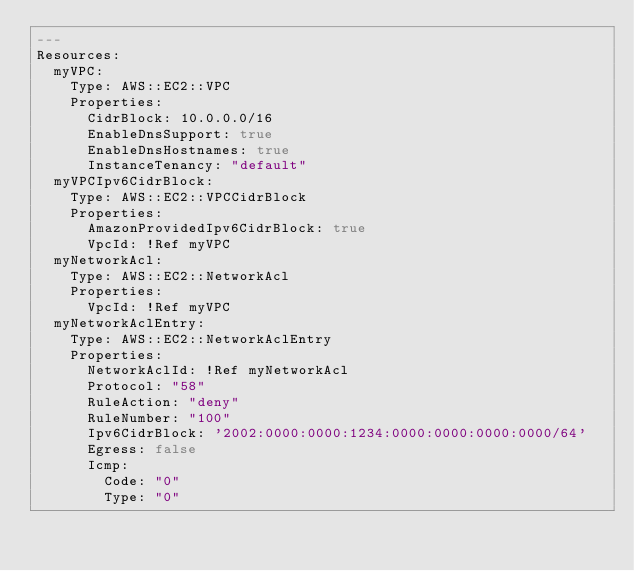<code> <loc_0><loc_0><loc_500><loc_500><_YAML_>---
Resources:
  myVPC:
    Type: AWS::EC2::VPC
    Properties:
      CidrBlock: 10.0.0.0/16
      EnableDnsSupport: true
      EnableDnsHostnames: true
      InstanceTenancy: "default"
  myVPCIpv6CidrBlock:
    Type: AWS::EC2::VPCCidrBlock
    Properties: 
      AmazonProvidedIpv6CidrBlock: true
      VpcId: !Ref myVPC
  myNetworkAcl:
    Type: AWS::EC2::NetworkAcl
    Properties:
      VpcId: !Ref myVPC
  myNetworkAclEntry:
    Type: AWS::EC2::NetworkAclEntry
    Properties:
      NetworkAclId: !Ref myNetworkAcl
      Protocol: "58"
      RuleAction: "deny"
      RuleNumber: "100"
      Ipv6CidrBlock: '2002:0000:0000:1234:0000:0000:0000:0000/64'
      Egress: false
      Icmp:
        Code: "0"
        Type: "0"
</code> 